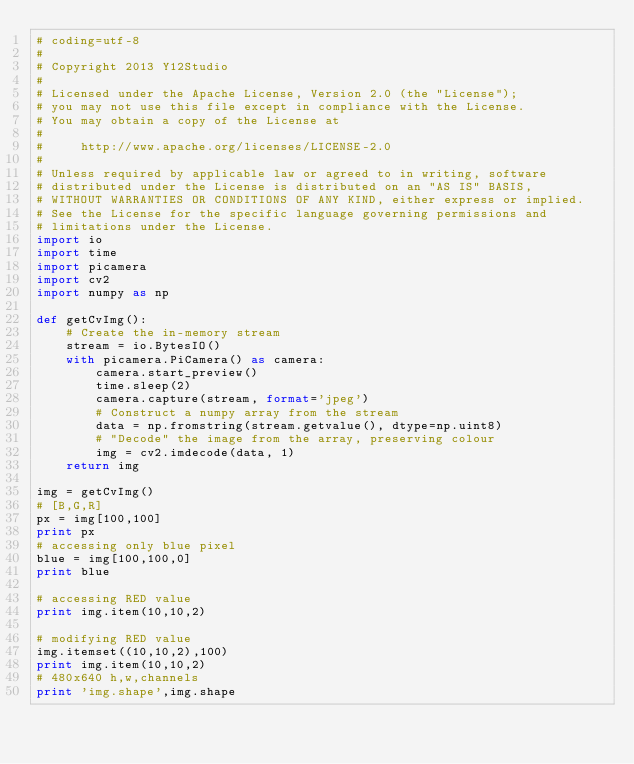Convert code to text. <code><loc_0><loc_0><loc_500><loc_500><_Python_># coding=utf-8
#
# Copyright 2013 Y12Studio
#
# Licensed under the Apache License, Version 2.0 (the "License");
# you may not use this file except in compliance with the License.
# You may obtain a copy of the License at
#
#     http://www.apache.org/licenses/LICENSE-2.0
#
# Unless required by applicable law or agreed to in writing, software
# distributed under the License is distributed on an "AS IS" BASIS,
# WITHOUT WARRANTIES OR CONDITIONS OF ANY KIND, either express or implied.
# See the License for the specific language governing permissions and
# limitations under the License.
import io
import time
import picamera
import cv2
import numpy as np

def getCvImg():
    # Create the in-memory stream
    stream = io.BytesIO()
    with picamera.PiCamera() as camera:
        camera.start_preview()
        time.sleep(2)
        camera.capture(stream, format='jpeg')
        # Construct a numpy array from the stream
        data = np.fromstring(stream.getvalue(), dtype=np.uint8)
        # "Decode" the image from the array, preserving colour
        img = cv2.imdecode(data, 1)
    return img
    
img = getCvImg()
# [B,G,R]
px = img[100,100]
print px
# accessing only blue pixel
blue = img[100,100,0]
print blue

# accessing RED value
print img.item(10,10,2)

# modifying RED value
img.itemset((10,10,2),100)
print img.item(10,10,2)
# 480x640 h,w,channels
print 'img.shape',img.shape</code> 